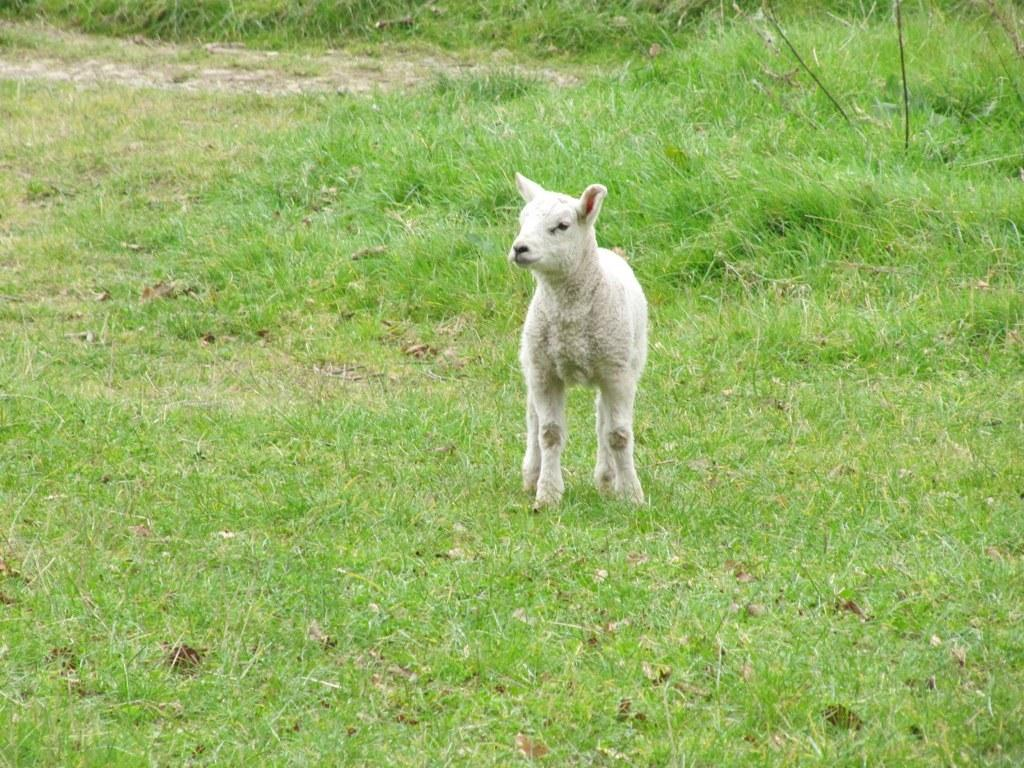What animal is present in the image? There is a lamb in the image. What is the lamb doing in the image? The lamb is standing on the ground. What type of surface is the lamb standing on? There is grass on the ground in the image. What type of music can be heard coming from the lamb in the image? There is no music coming from the lamb in the image, as it is an animal and not capable of producing music. 